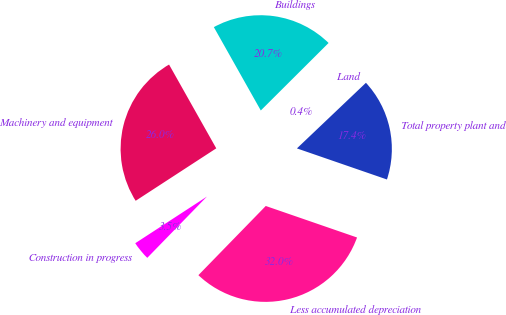<chart> <loc_0><loc_0><loc_500><loc_500><pie_chart><fcel>Land<fcel>Buildings<fcel>Machinery and equipment<fcel>Construction in progress<fcel>Less accumulated depreciation<fcel>Total property plant and<nl><fcel>0.37%<fcel>20.7%<fcel>26.02%<fcel>3.53%<fcel>32.0%<fcel>17.39%<nl></chart> 